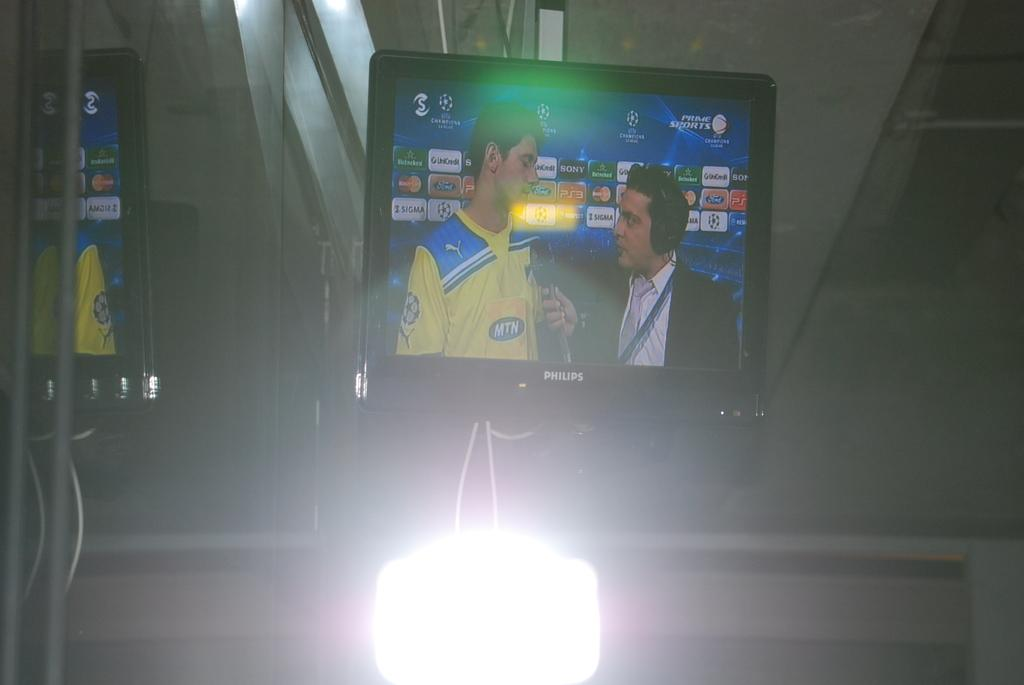Provide a one-sentence caption for the provided image. A Phillips TV showing an athlete getting interviewed. 